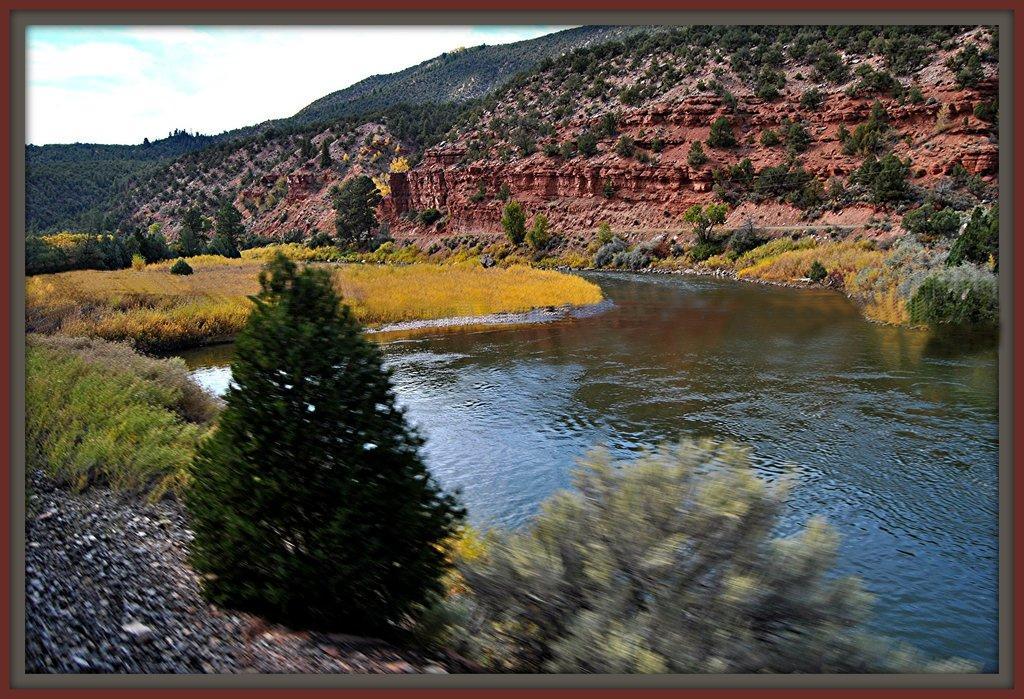In one or two sentences, can you explain what this image depicts? In this image we can see a photo and it looks like a photo frame and there are some plants, trees and grass on the ground and we can see the water and we can see the mountains in the background and at the top we can see the sky. 